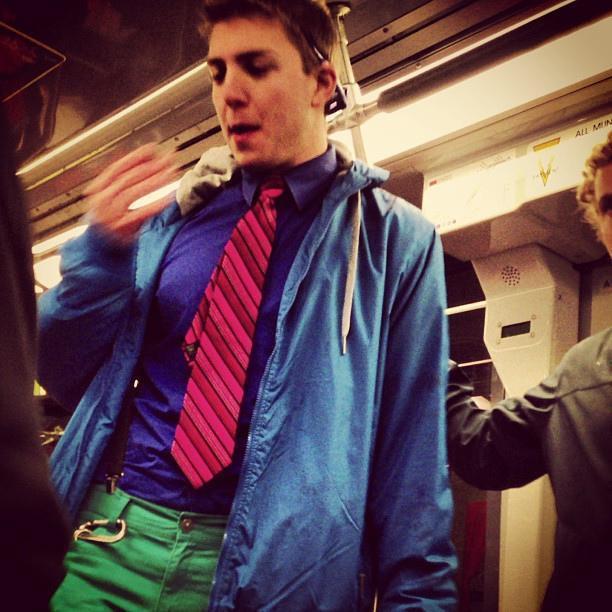How many people are in the picture?
Give a very brief answer. 3. 